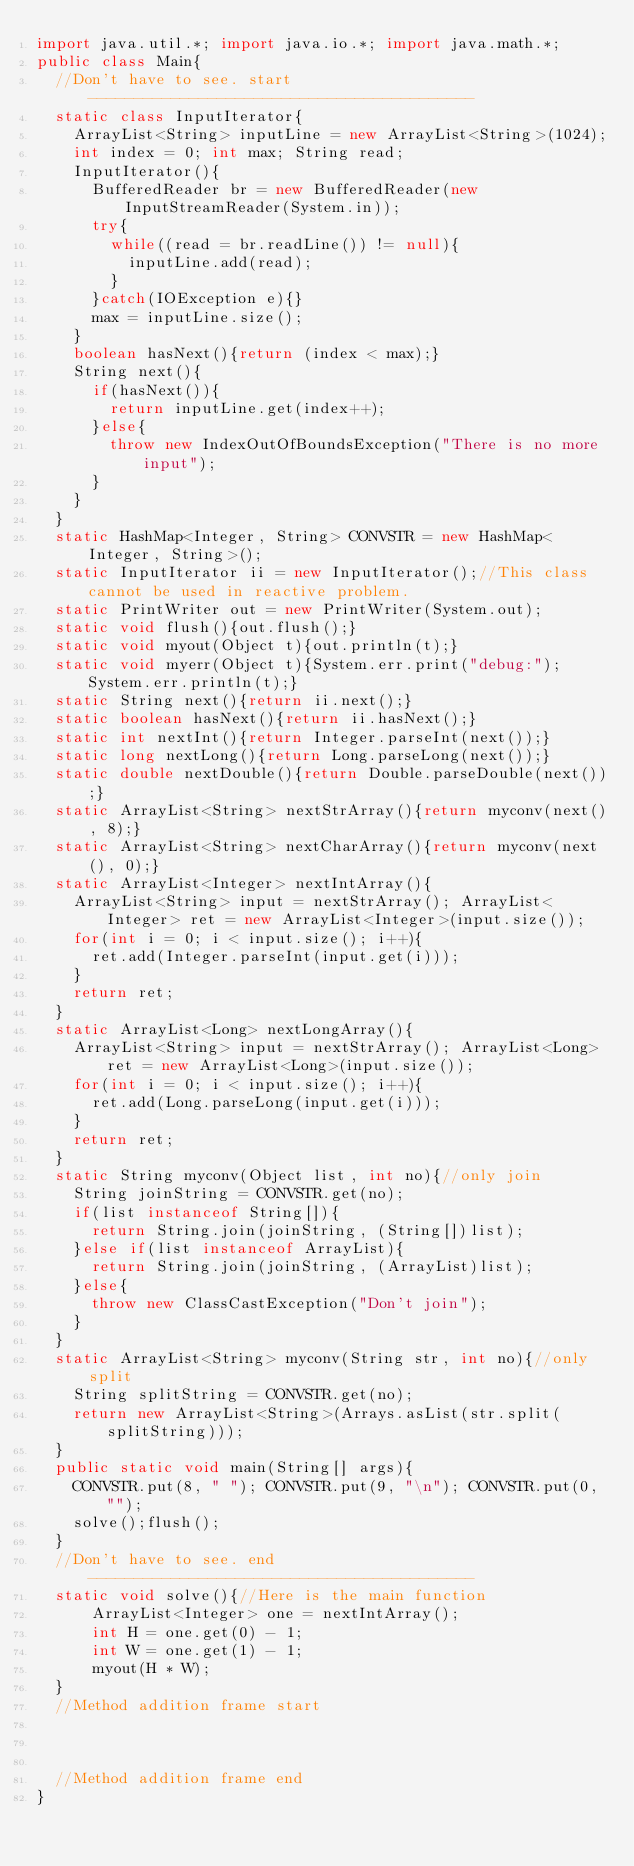<code> <loc_0><loc_0><loc_500><loc_500><_Java_>import java.util.*; import java.io.*; import java.math.*;
public class Main{
	//Don't have to see. start------------------------------------------
	static class InputIterator{
		ArrayList<String> inputLine = new ArrayList<String>(1024);
		int index = 0; int max; String read;
		InputIterator(){
			BufferedReader br = new BufferedReader(new InputStreamReader(System.in));
			try{
				while((read = br.readLine()) != null){
					inputLine.add(read);
				}
			}catch(IOException e){}
			max = inputLine.size();
		}
		boolean hasNext(){return (index < max);}
		String next(){
			if(hasNext()){
				return inputLine.get(index++);
			}else{
				throw new IndexOutOfBoundsException("There is no more input");
			}
		}
	}
	static HashMap<Integer, String> CONVSTR = new HashMap<Integer, String>();
	static InputIterator ii = new InputIterator();//This class cannot be used in reactive problem.
	static PrintWriter out = new PrintWriter(System.out);
	static void flush(){out.flush();}
	static void myout(Object t){out.println(t);}
	static void myerr(Object t){System.err.print("debug:");System.err.println(t);}
	static String next(){return ii.next();}
	static boolean hasNext(){return ii.hasNext();}
	static int nextInt(){return Integer.parseInt(next());}
	static long nextLong(){return Long.parseLong(next());}
	static double nextDouble(){return Double.parseDouble(next());}
	static ArrayList<String> nextStrArray(){return myconv(next(), 8);}
	static ArrayList<String> nextCharArray(){return myconv(next(), 0);}
	static ArrayList<Integer> nextIntArray(){
		ArrayList<String> input = nextStrArray(); ArrayList<Integer> ret = new ArrayList<Integer>(input.size());
		for(int i = 0; i < input.size(); i++){
			ret.add(Integer.parseInt(input.get(i)));
		}
		return ret;
	}
	static ArrayList<Long> nextLongArray(){
		ArrayList<String> input = nextStrArray(); ArrayList<Long> ret = new ArrayList<Long>(input.size());
		for(int i = 0; i < input.size(); i++){
			ret.add(Long.parseLong(input.get(i)));
		}
		return ret;
	}
	static String myconv(Object list, int no){//only join
		String joinString = CONVSTR.get(no);
		if(list instanceof String[]){
			return String.join(joinString, (String[])list);
		}else if(list instanceof ArrayList){
			return String.join(joinString, (ArrayList)list);
		}else{
			throw new ClassCastException("Don't join");
		}
	}
	static ArrayList<String> myconv(String str, int no){//only split
		String splitString = CONVSTR.get(no);
		return new ArrayList<String>(Arrays.asList(str.split(splitString)));
	}
	public static void main(String[] args){
		CONVSTR.put(8, " "); CONVSTR.put(9, "\n"); CONVSTR.put(0, "");
		solve();flush();
	}
	//Don't have to see. end------------------------------------------
	static void solve(){//Here is the main function
      ArrayList<Integer> one = nextIntArray();
      int H = one.get(0) - 1;
      int W = one.get(1) - 1;
      myout(H * W);
	}
	//Method addition frame start



	//Method addition frame end
}
</code> 